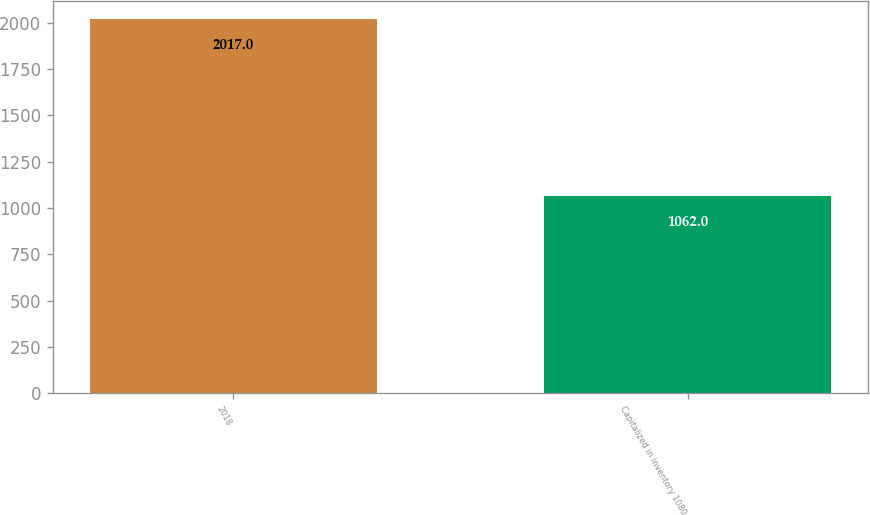Convert chart. <chart><loc_0><loc_0><loc_500><loc_500><bar_chart><fcel>2018<fcel>Capitalized in inventory 1080<nl><fcel>2017<fcel>1062<nl></chart> 